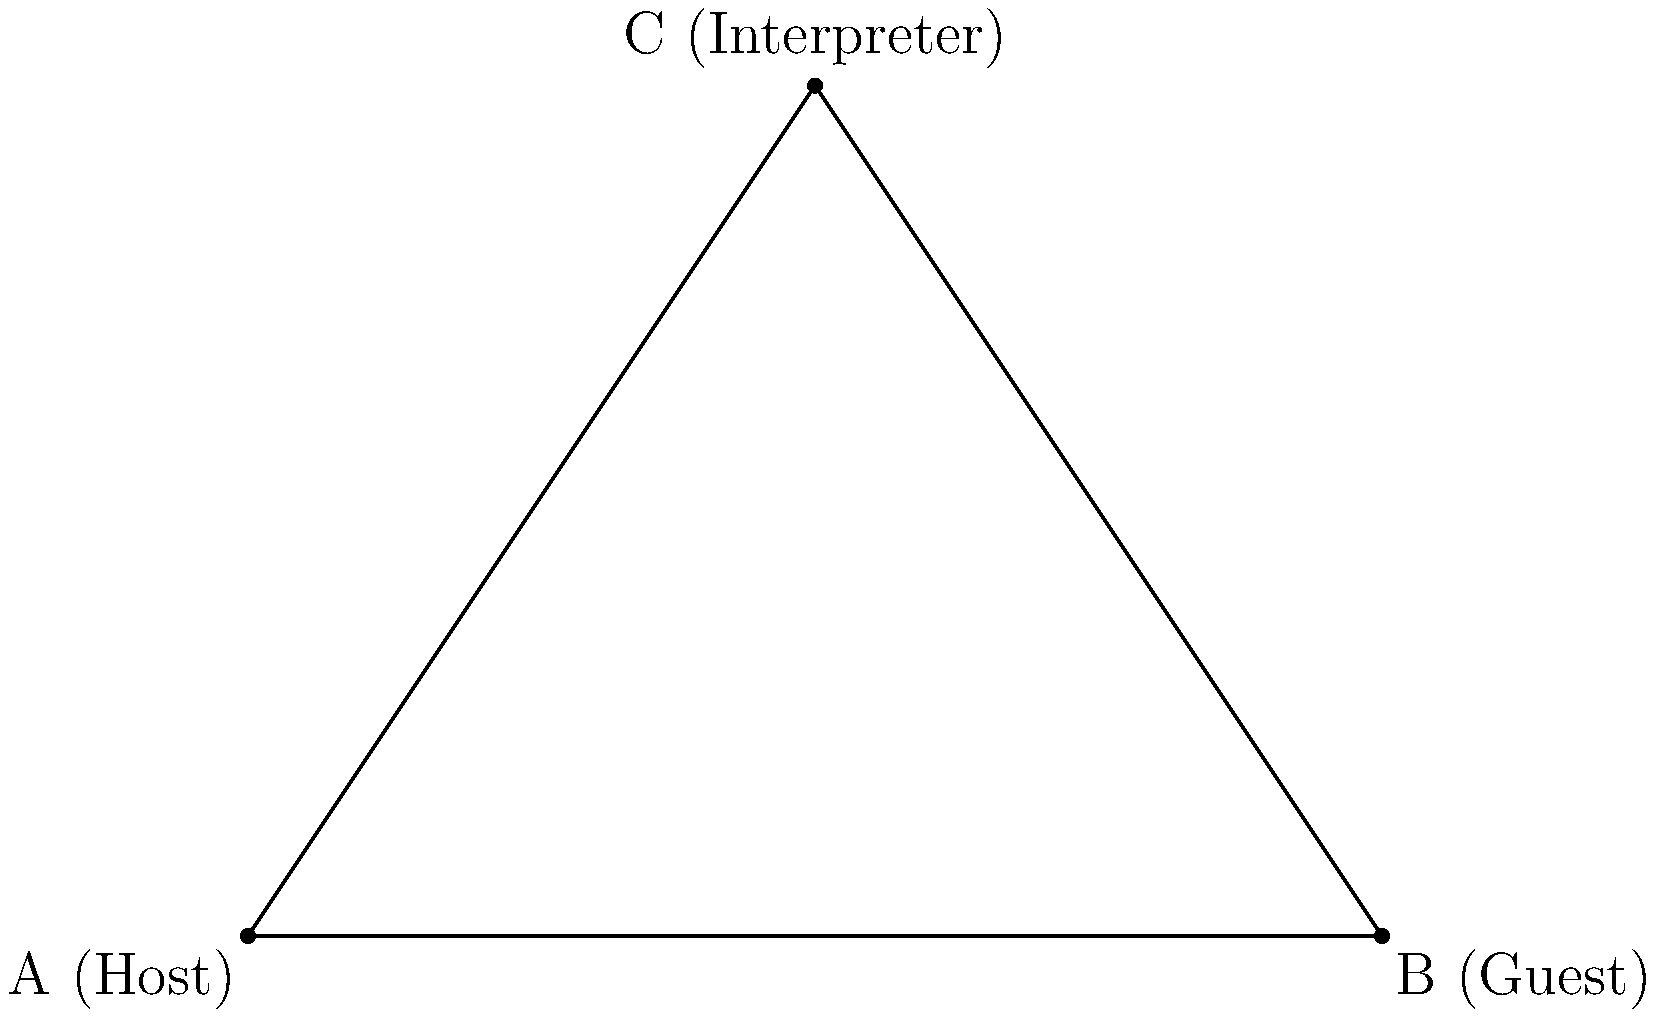In a diplomatic reception, a host (A), guest (B), and interpreter (C) form a triangular formation. The distance between the host and guest is 8 meters, and the interpreter stands 6 meters away from the host at a 30° angle. What is the distance between the guest and the interpreter, rounded to the nearest tenth of a meter? Let's approach this step-by-step using trigonometry:

1) We have a triangle ABC where:
   - AB = 8 meters (distance between host and guest)
   - AC = 6 meters (distance between host and interpreter)
   - Angle CAB = 30°

2) We need to find BC (distance between guest and interpreter).

3) We can use the law of cosines:
   $$BC^2 = AB^2 + AC^2 - 2(AB)(AC)\cos(\angle CAB)$$

4) Substituting the known values:
   $$BC^2 = 8^2 + 6^2 - 2(8)(6)\cos(30°)$$

5) Simplify:
   $$BC^2 = 64 + 36 - 96\cos(30°)$$

6) $\cos(30°) = \frac{\sqrt{3}}{2}$, so:
   $$BC^2 = 64 + 36 - 96(\frac{\sqrt{3}}{2})$$
   $$BC^2 = 100 - 48\sqrt{3}$$

7) Taking the square root of both sides:
   $$BC = \sqrt{100 - 48\sqrt{3}}$$

8) Using a calculator and rounding to the nearest tenth:
   $$BC \approx 4.6 \text{ meters}$$
Answer: 4.6 meters 